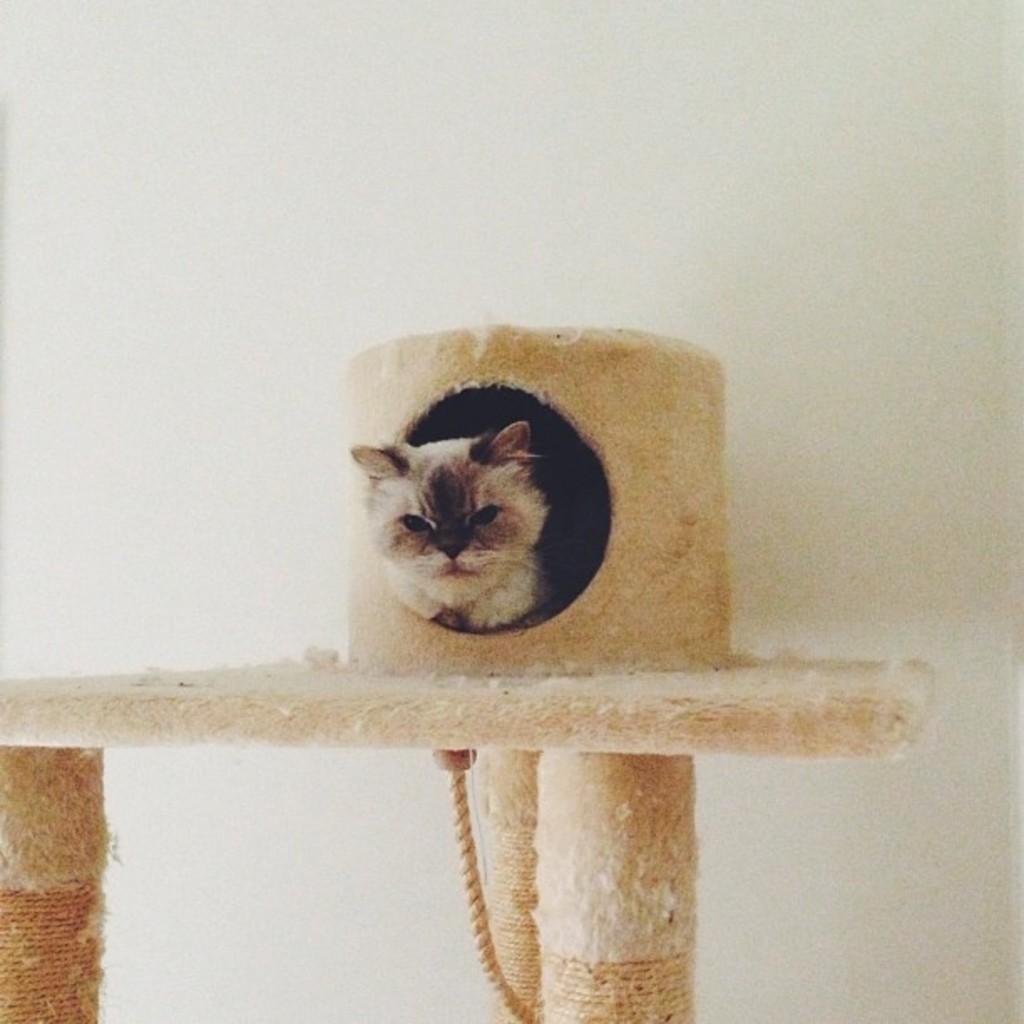Describe this image in one or two sentences. Inside this hole we can see a cat. Under the surface there is a rope. Background there is a white wall. 